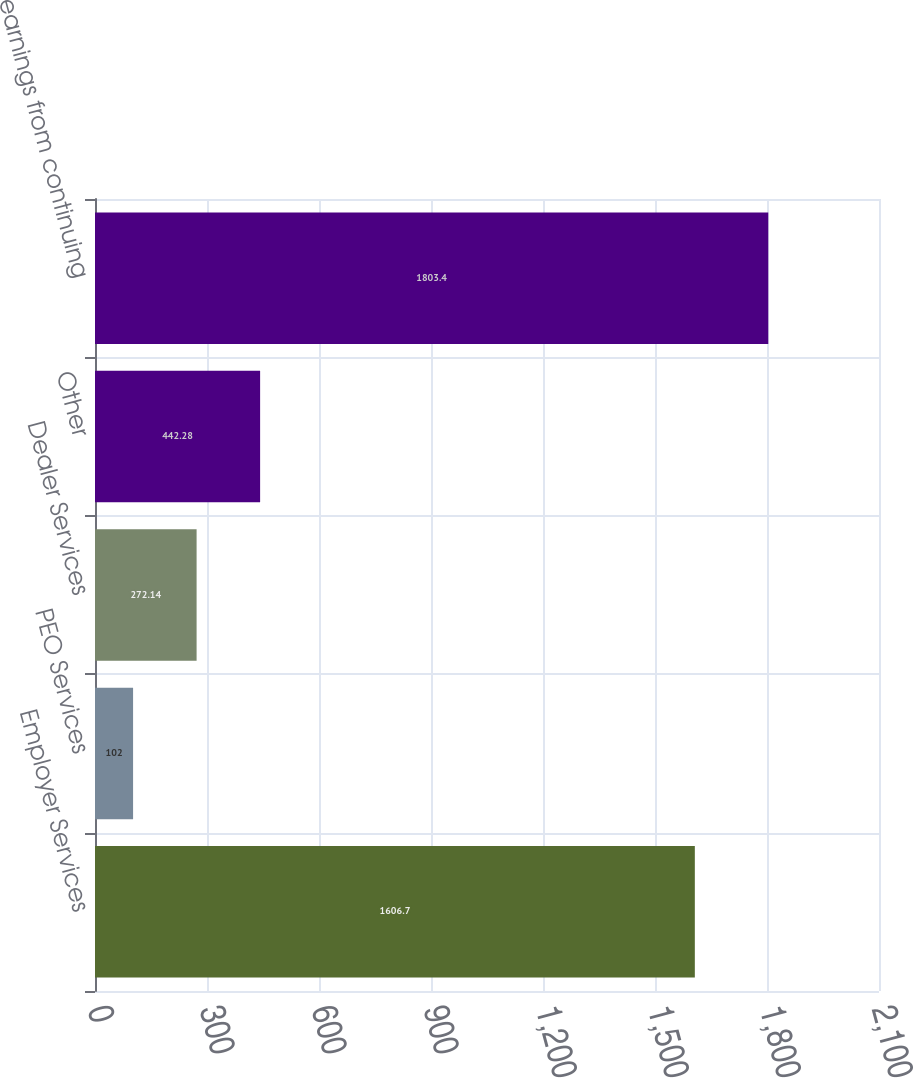Convert chart. <chart><loc_0><loc_0><loc_500><loc_500><bar_chart><fcel>Employer Services<fcel>PEO Services<fcel>Dealer Services<fcel>Other<fcel>Total earnings from continuing<nl><fcel>1606.7<fcel>102<fcel>272.14<fcel>442.28<fcel>1803.4<nl></chart> 